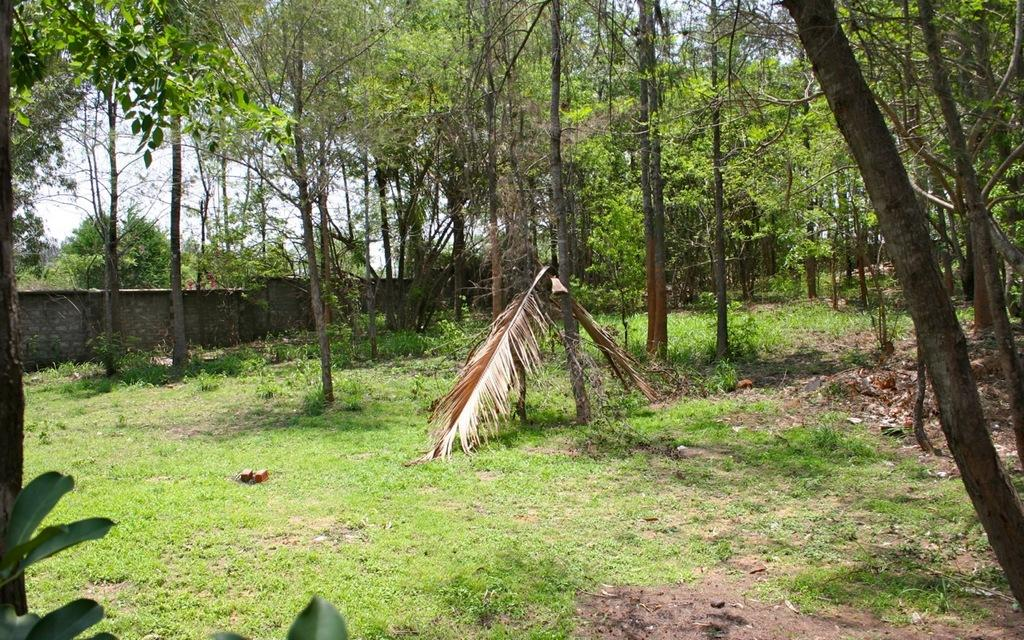What type of vegetation covers the land in the image? The land is covered with grass. What type of structure can be seen in the image? There is a wall in the image. What other natural elements are present in the image? There are trees in the image. How many legs can be seen on the party in the image? There is no party present in the image, and therefore no legs can be seen. 